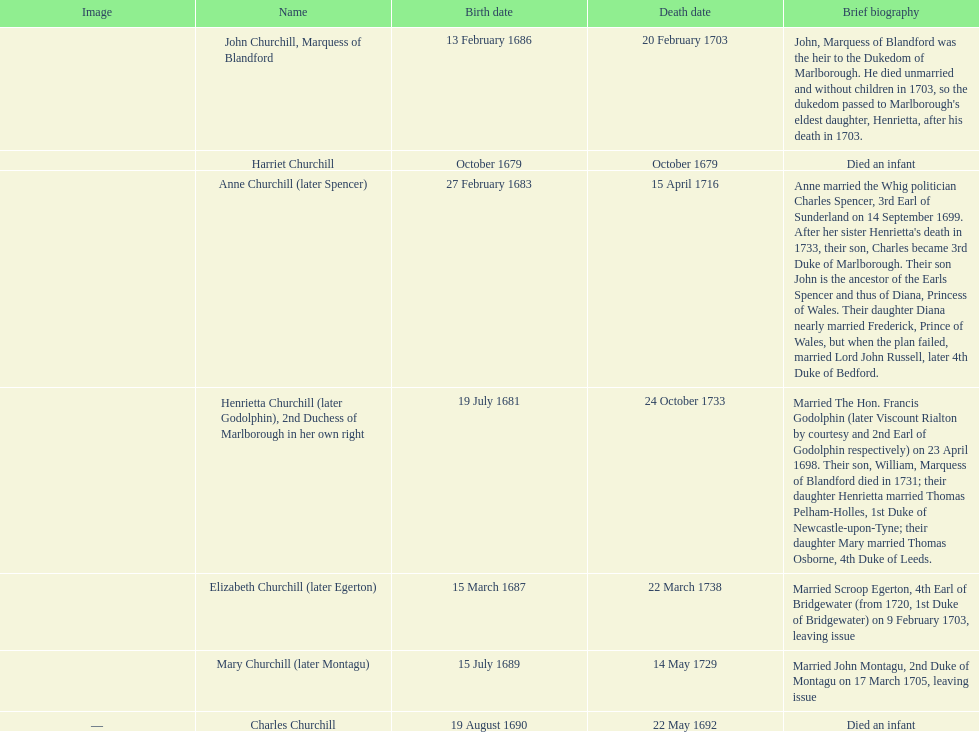What is the number of children sarah churchill had? 7. 